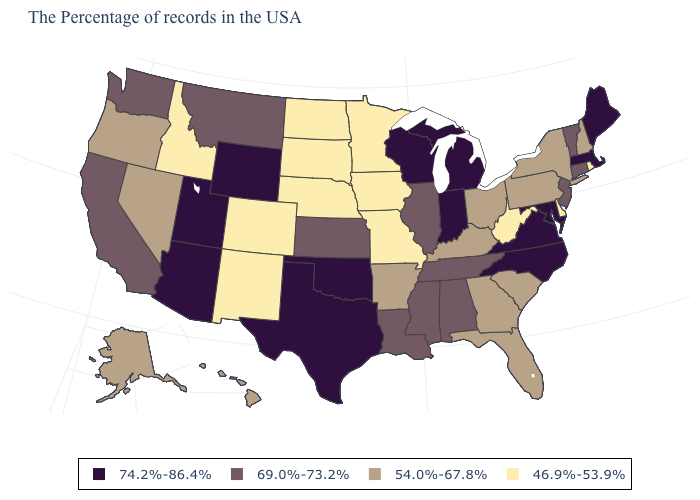Name the states that have a value in the range 74.2%-86.4%?
Answer briefly. Maine, Massachusetts, Maryland, Virginia, North Carolina, Michigan, Indiana, Wisconsin, Oklahoma, Texas, Wyoming, Utah, Arizona. Among the states that border Connecticut , which have the lowest value?
Answer briefly. Rhode Island. Which states have the highest value in the USA?
Be succinct. Maine, Massachusetts, Maryland, Virginia, North Carolina, Michigan, Indiana, Wisconsin, Oklahoma, Texas, Wyoming, Utah, Arizona. Is the legend a continuous bar?
Concise answer only. No. Name the states that have a value in the range 69.0%-73.2%?
Keep it brief. Vermont, Connecticut, New Jersey, Alabama, Tennessee, Illinois, Mississippi, Louisiana, Kansas, Montana, California, Washington. What is the highest value in the South ?
Give a very brief answer. 74.2%-86.4%. Is the legend a continuous bar?
Quick response, please. No. What is the value of Oregon?
Answer briefly. 54.0%-67.8%. Does Massachusetts have the lowest value in the Northeast?
Give a very brief answer. No. Which states hav the highest value in the Northeast?
Be succinct. Maine, Massachusetts. Does Nevada have a lower value than West Virginia?
Short answer required. No. Is the legend a continuous bar?
Concise answer only. No. Does Wisconsin have the highest value in the MidWest?
Answer briefly. Yes. Is the legend a continuous bar?
Keep it brief. No. Name the states that have a value in the range 46.9%-53.9%?
Short answer required. Rhode Island, Delaware, West Virginia, Missouri, Minnesota, Iowa, Nebraska, South Dakota, North Dakota, Colorado, New Mexico, Idaho. 